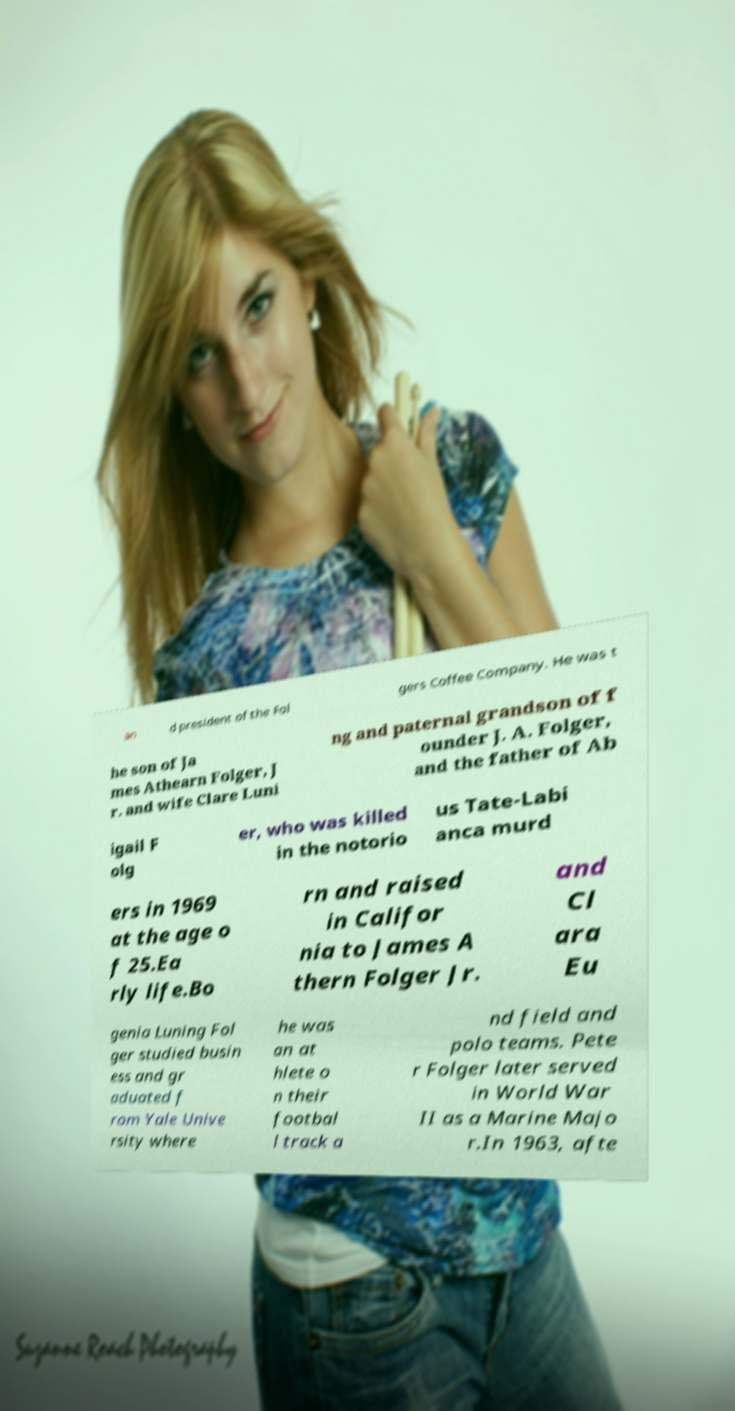Could you extract and type out the text from this image? an d president of the Fol gers Coffee Company. He was t he son of Ja mes Athearn Folger, J r. and wife Clare Luni ng and paternal grandson of f ounder J. A. Folger, and the father of Ab igail F olg er, who was killed in the notorio us Tate-Labi anca murd ers in 1969 at the age o f 25.Ea rly life.Bo rn and raised in Califor nia to James A thern Folger Jr. and Cl ara Eu genia Luning Fol ger studied busin ess and gr aduated f rom Yale Unive rsity where he was an at hlete o n their footbal l track a nd field and polo teams. Pete r Folger later served in World War II as a Marine Majo r.In 1963, afte 